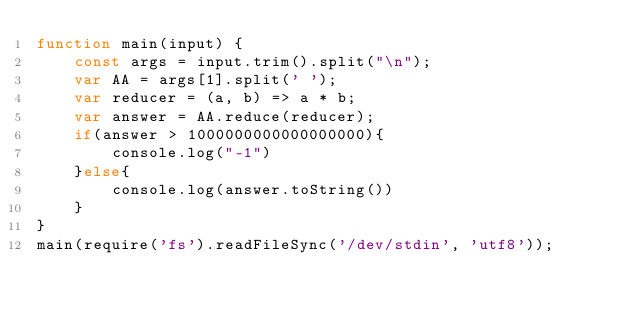Convert code to text. <code><loc_0><loc_0><loc_500><loc_500><_JavaScript_>function main(input) {
    const args = input.trim().split("\n");
    var AA = args[1].split(' ');
    var reducer = (a, b) => a * b;
    var answer = AA.reduce(reducer);
    if(answer > 1000000000000000000){
        console.log("-1")
    }else{
        console.log(answer.toString())
    }
}
main(require('fs').readFileSync('/dev/stdin', 'utf8'));</code> 